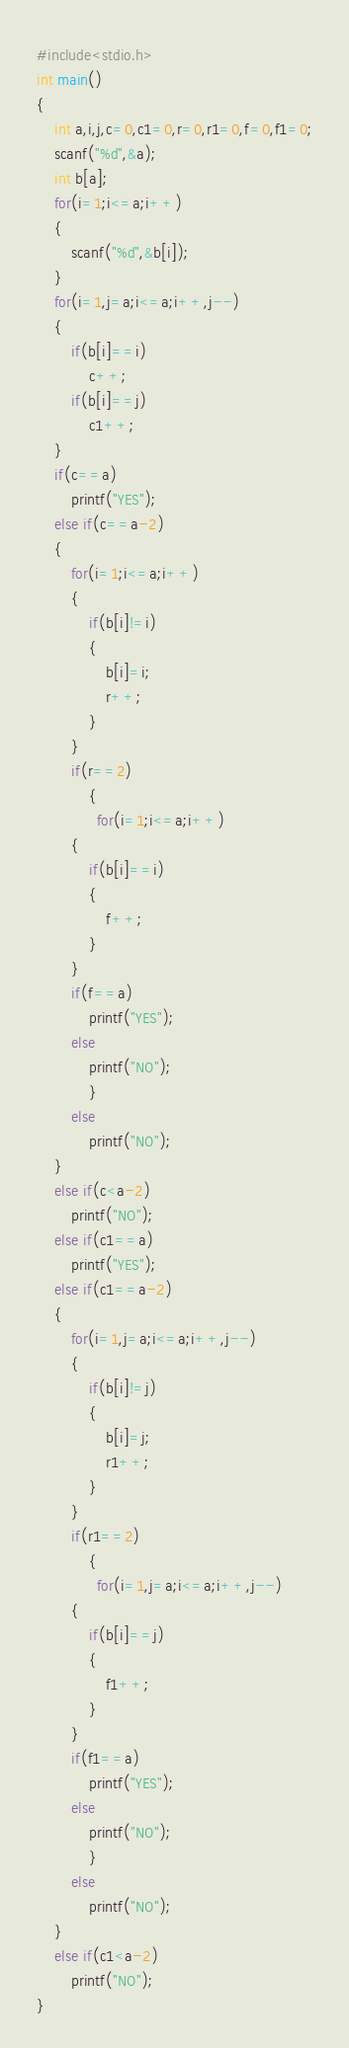Convert code to text. <code><loc_0><loc_0><loc_500><loc_500><_C_>#include<stdio.h>
int main()
{
    int a,i,j,c=0,c1=0,r=0,r1=0,f=0,f1=0;
    scanf("%d",&a);
    int b[a];
    for(i=1;i<=a;i++)
    {
        scanf("%d",&b[i]);
    }
    for(i=1,j=a;i<=a;i++,j--)
    {
        if(b[i]==i)
            c++;
        if(b[i]==j)
            c1++;
    }
    if(c==a)
        printf("YES");
    else if(c==a-2)
    {
        for(i=1;i<=a;i++)
        {
            if(b[i]!=i)
            {
                b[i]=i;
                r++;
            }
        }
        if(r==2)
            {
              for(i=1;i<=a;i++)
        {
            if(b[i]==i)
            {
                f++;
            }
        }
        if(f==a)
            printf("YES");
        else
            printf("NO");
            }
        else
            printf("NO");
    }
    else if(c<a-2)
        printf("NO");
    else if(c1==a)
        printf("YES");
    else if(c1==a-2)
    {
        for(i=1,j=a;i<=a;i++,j--)
        {
            if(b[i]!=j)
            {
                b[i]=j;
                r1++;
            }
        }
        if(r1==2)
            {
              for(i=1,j=a;i<=a;i++,j--)
        {
            if(b[i]==j)
            {
                f1++;
            }
        }
        if(f1==a)
            printf("YES");
        else
            printf("NO");
            }
        else
            printf("NO");
    }
    else if(c1<a-2)
        printf("NO");
}</code> 